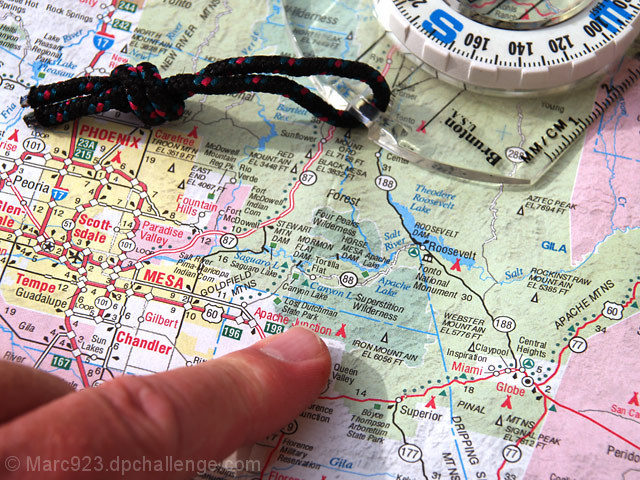What specific location is the finger pointing to on the map? The finger is pointing to an area near Apache Junction, which is located in the state of Arizona, United States. 